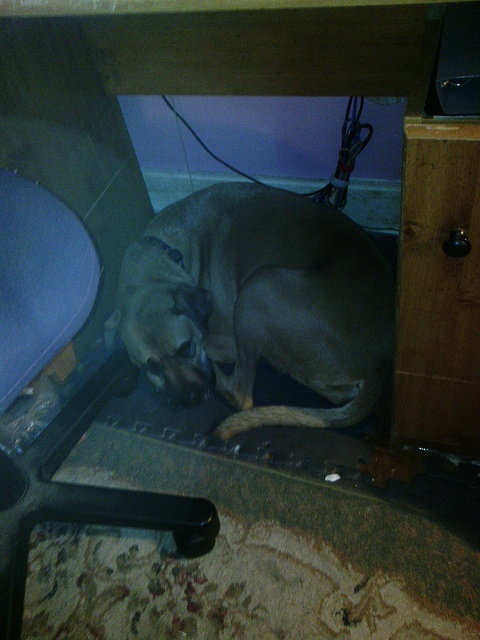Describe the objects in this image and their specific colors. I can see dog in gray, black, blue, and darkblue tones and chair in gray, blue, and darkblue tones in this image. 